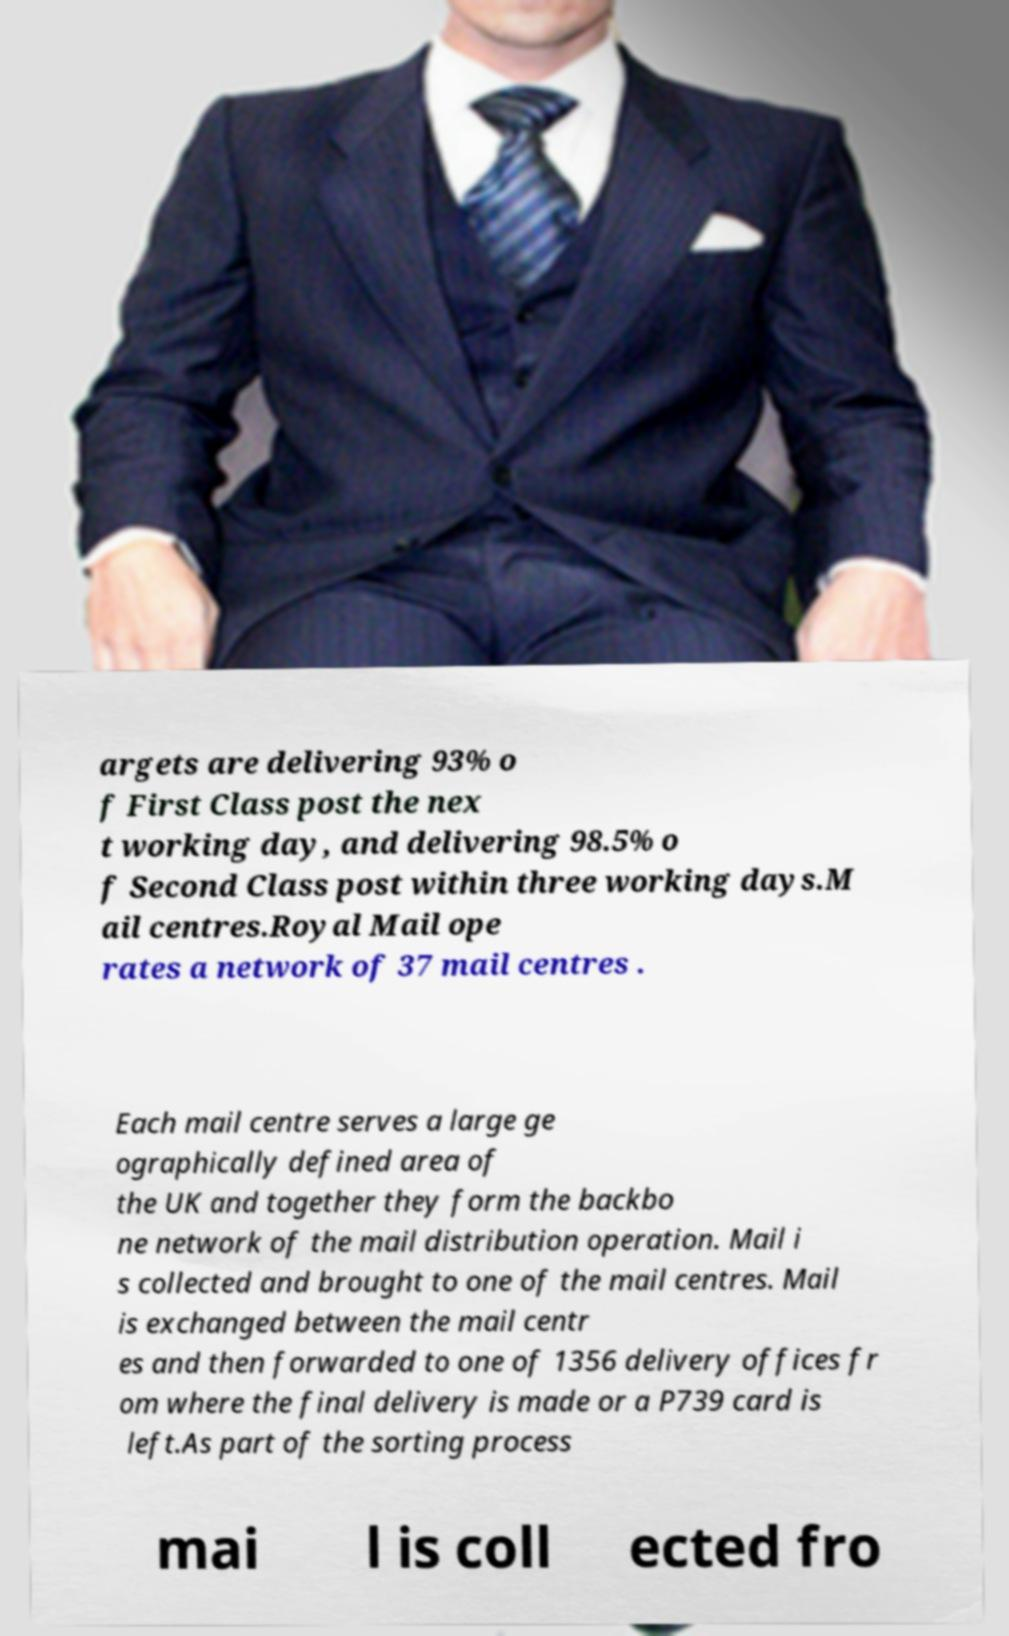Please identify and transcribe the text found in this image. argets are delivering 93% o f First Class post the nex t working day, and delivering 98.5% o f Second Class post within three working days.M ail centres.Royal Mail ope rates a network of 37 mail centres . Each mail centre serves a large ge ographically defined area of the UK and together they form the backbo ne network of the mail distribution operation. Mail i s collected and brought to one of the mail centres. Mail is exchanged between the mail centr es and then forwarded to one of 1356 delivery offices fr om where the final delivery is made or a P739 card is left.As part of the sorting process mai l is coll ected fro 